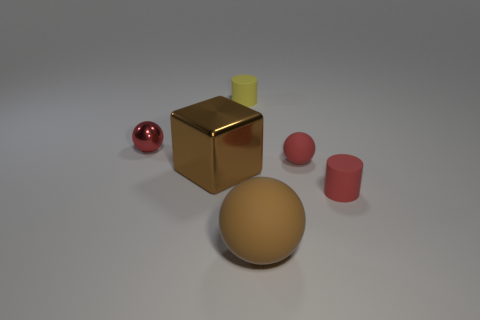Subtract all shiny spheres. How many spheres are left? 2 Subtract all gray blocks. How many red spheres are left? 2 Subtract all red balls. How many balls are left? 1 Subtract 1 spheres. How many spheres are left? 2 Subtract all cubes. How many objects are left? 5 Add 4 yellow matte things. How many objects exist? 10 Subtract 0 cyan cubes. How many objects are left? 6 Subtract all blue blocks. Subtract all cyan balls. How many blocks are left? 1 Subtract all big blocks. Subtract all big yellow balls. How many objects are left? 5 Add 5 small yellow matte objects. How many small yellow matte objects are left? 6 